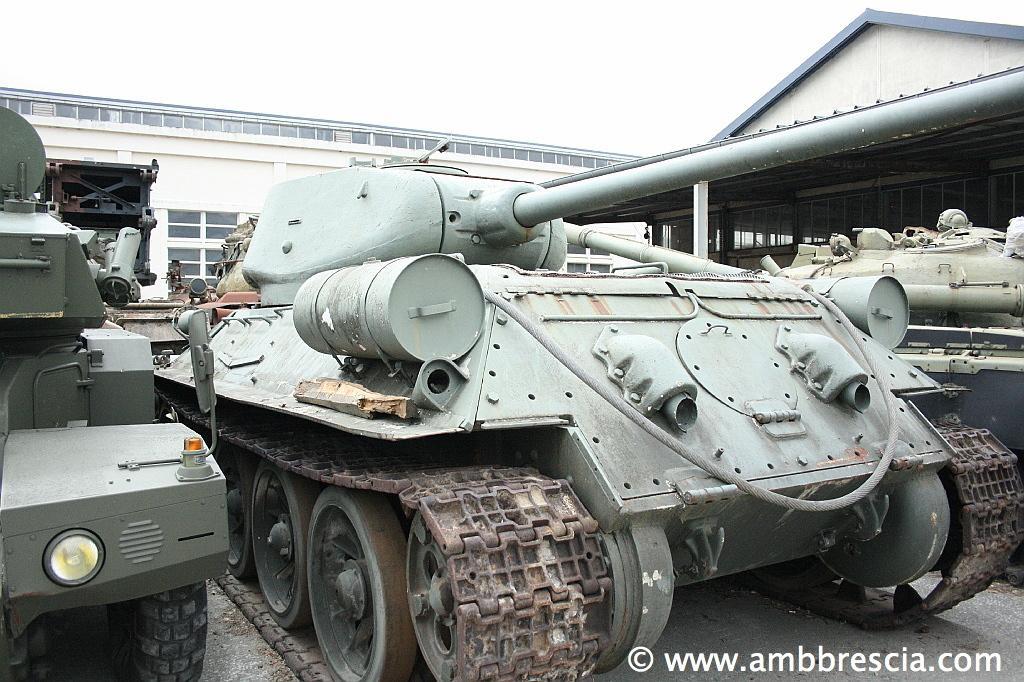Please provide a concise description of this image. As we can see in the image there are vehicles, buildings and sky. 